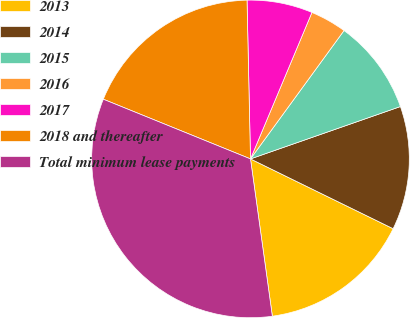<chart> <loc_0><loc_0><loc_500><loc_500><pie_chart><fcel>2013<fcel>2014<fcel>2015<fcel>2016<fcel>2017<fcel>2018 and thereafter<fcel>Total minimum lease payments<nl><fcel>15.56%<fcel>12.59%<fcel>9.63%<fcel>3.7%<fcel>6.67%<fcel>18.52%<fcel>33.33%<nl></chart> 